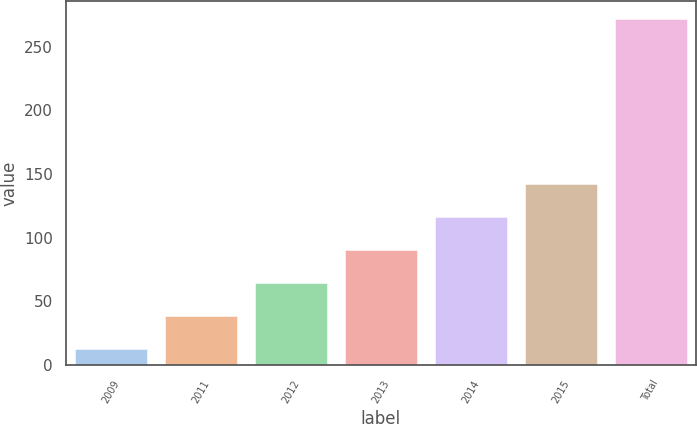Convert chart. <chart><loc_0><loc_0><loc_500><loc_500><bar_chart><fcel>2009<fcel>2011<fcel>2012<fcel>2013<fcel>2014<fcel>2015<fcel>Total<nl><fcel>13<fcel>38.9<fcel>64.8<fcel>90.7<fcel>116.6<fcel>142.5<fcel>272<nl></chart> 